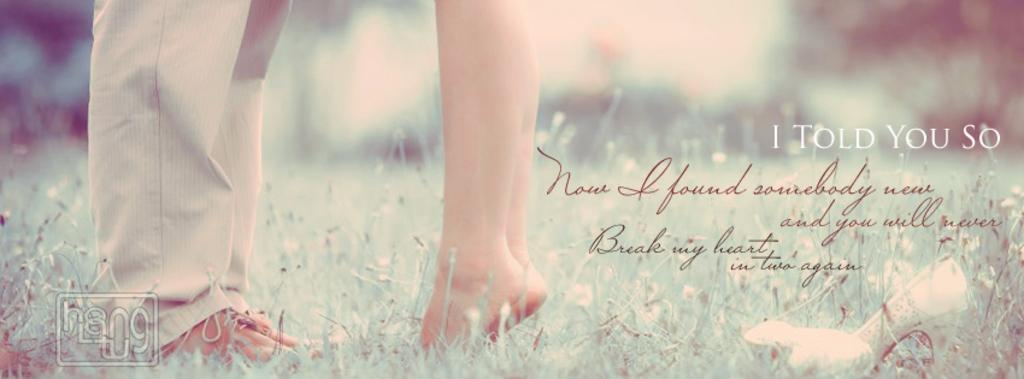What is the main subject of the poster in the image? The poster contains images of persons' legs. What type of background is depicted in the poster? There is grass depicted in the poster. Is there any text present in the poster? Yes, there is text present in the poster. What type of lip can be seen on the map in the image? There is no map present in the image, and therefore no lip can be seen on it. 